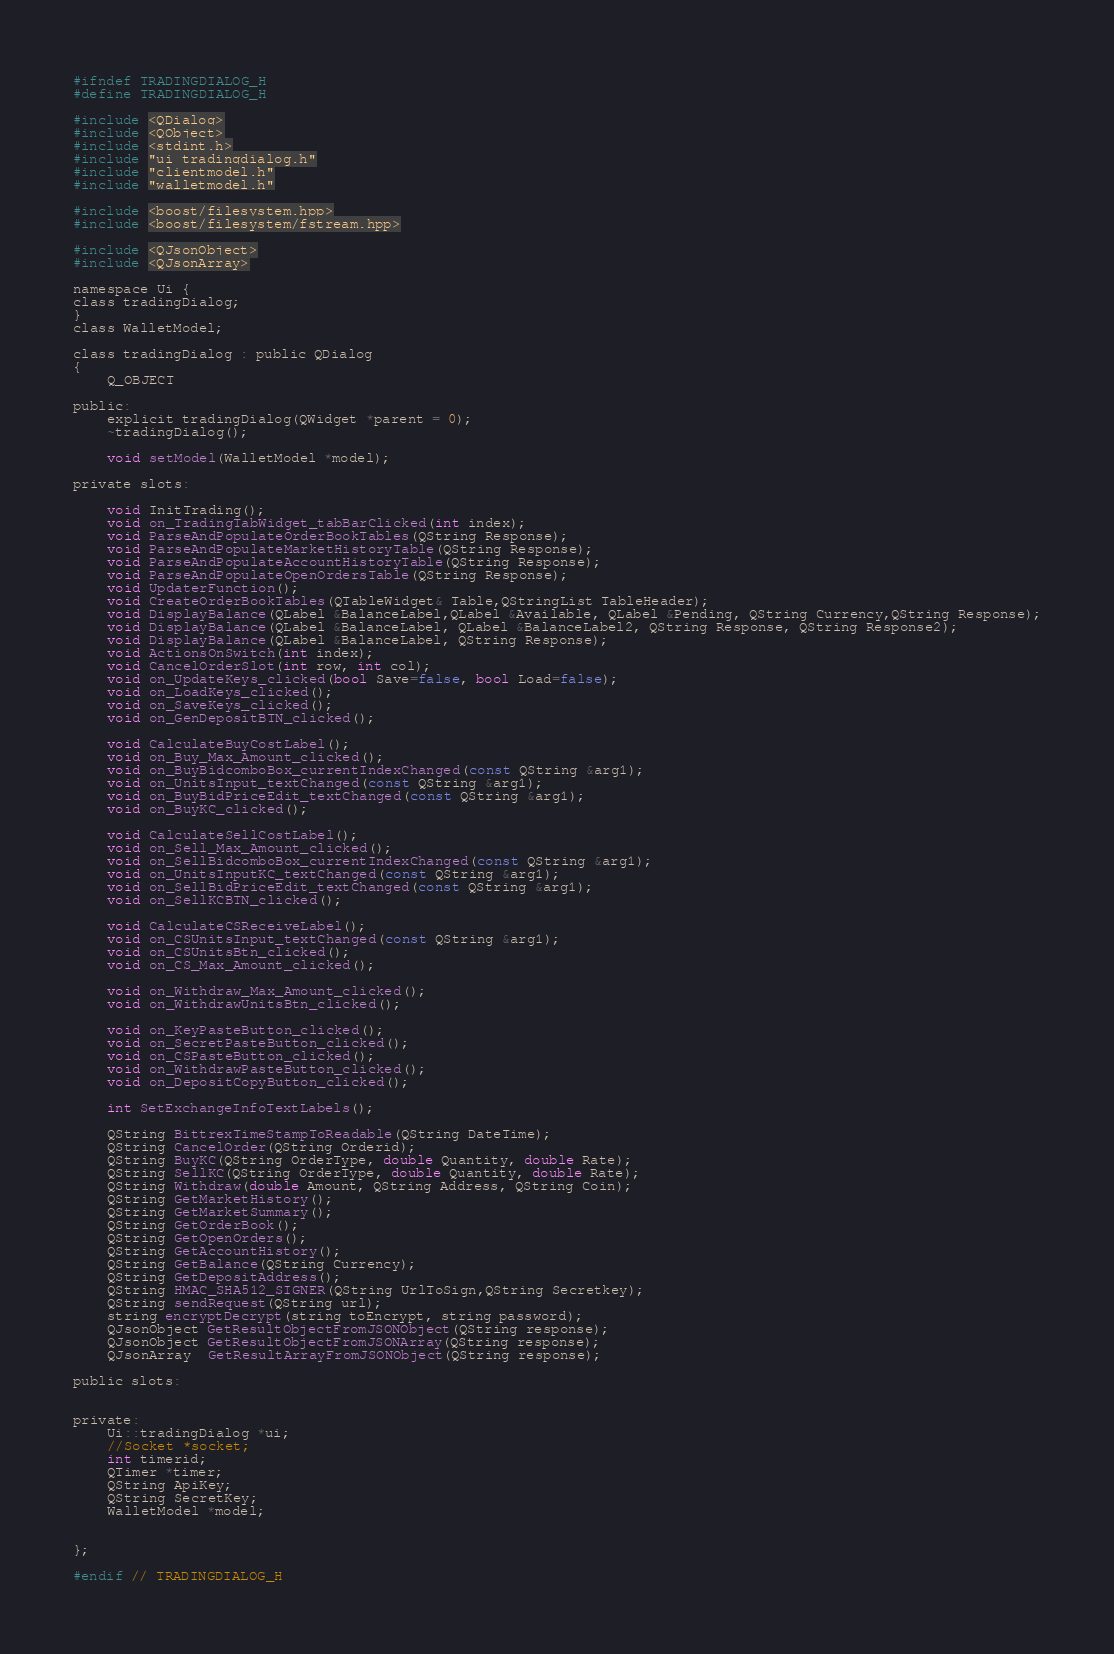<code> <loc_0><loc_0><loc_500><loc_500><_C_>
#ifndef TRADINGDIALOG_H
#define TRADINGDIALOG_H

#include <QDialog>
#include <QObject>
#include <stdint.h>
#include "ui_tradingdialog.h"
#include "clientmodel.h"
#include "walletmodel.h"

#include <boost/filesystem.hpp>
#include <boost/filesystem/fstream.hpp>

#include <QJsonObject>
#include <QJsonArray>

namespace Ui {
class tradingDialog;
}
class WalletModel;

class tradingDialog : public QDialog
{
    Q_OBJECT

public:
    explicit tradingDialog(QWidget *parent = 0);
    ~tradingDialog();

    void setModel(WalletModel *model);

private slots:

    void InitTrading();
    void on_TradingTabWidget_tabBarClicked(int index);
    void ParseAndPopulateOrderBookTables(QString Response);
    void ParseAndPopulateMarketHistoryTable(QString Response);
    void ParseAndPopulateAccountHistoryTable(QString Response);
    void ParseAndPopulateOpenOrdersTable(QString Response);
    void UpdaterFunction();
    void CreateOrderBookTables(QTableWidget& Table,QStringList TableHeader);
    void DisplayBalance(QLabel &BalanceLabel,QLabel &Available, QLabel &Pending, QString Currency,QString Response);
    void DisplayBalance(QLabel &BalanceLabel, QLabel &BalanceLabel2, QString Response, QString Response2);
    void DisplayBalance(QLabel &BalanceLabel, QString Response);
    void ActionsOnSwitch(int index);
    void CancelOrderSlot(int row, int col);
    void on_UpdateKeys_clicked(bool Save=false, bool Load=false);
    void on_LoadKeys_clicked();
    void on_SaveKeys_clicked();
    void on_GenDepositBTN_clicked();

    void CalculateBuyCostLabel();
    void on_Buy_Max_Amount_clicked();
    void on_BuyBidcomboBox_currentIndexChanged(const QString &arg1);
    void on_UnitsInput_textChanged(const QString &arg1);
    void on_BuyBidPriceEdit_textChanged(const QString &arg1);
    void on_BuyKC_clicked();

    void CalculateSellCostLabel();
    void on_Sell_Max_Amount_clicked();
    void on_SellBidcomboBox_currentIndexChanged(const QString &arg1);
    void on_UnitsInputKC_textChanged(const QString &arg1);
    void on_SellBidPriceEdit_textChanged(const QString &arg1);
    void on_SellKCBTN_clicked();

    void CalculateCSReceiveLabel();
    void on_CSUnitsInput_textChanged(const QString &arg1);
    void on_CSUnitsBtn_clicked();
    void on_CS_Max_Amount_clicked();

    void on_Withdraw_Max_Amount_clicked();
    void on_WithdrawUnitsBtn_clicked();

    void on_KeyPasteButton_clicked();
    void on_SecretPasteButton_clicked();
    void on_CSPasteButton_clicked();
    void on_WithdrawPasteButton_clicked();
    void on_DepositCopyButton_clicked();

    int SetExchangeInfoTextLabels();

    QString BittrexTimeStampToReadable(QString DateTime);
    QString CancelOrder(QString Orderid);
    QString BuyKC(QString OrderType, double Quantity, double Rate);
    QString SellKC(QString OrderType, double Quantity, double Rate);
    QString Withdraw(double Amount, QString Address, QString Coin);
    QString GetMarketHistory();
    QString GetMarketSummary();
    QString GetOrderBook();
    QString GetOpenOrders();
    QString GetAccountHistory();
    QString GetBalance(QString Currency);
    QString GetDepositAddress();
    QString HMAC_SHA512_SIGNER(QString UrlToSign,QString Secretkey);
    QString sendRequest(QString url);
    string encryptDecrypt(string toEncrypt, string password);
    QJsonObject GetResultObjectFromJSONObject(QString response);
    QJsonObject GetResultObjectFromJSONArray(QString response);
    QJsonArray  GetResultArrayFromJSONObject(QString response);

public slots:


private:
    Ui::tradingDialog *ui;
    //Socket *socket;
    int timerid;
    QTimer *timer;
    QString ApiKey;
    QString SecretKey;
    WalletModel *model;


};

#endif // TRADINGDIALOG_H</code> 